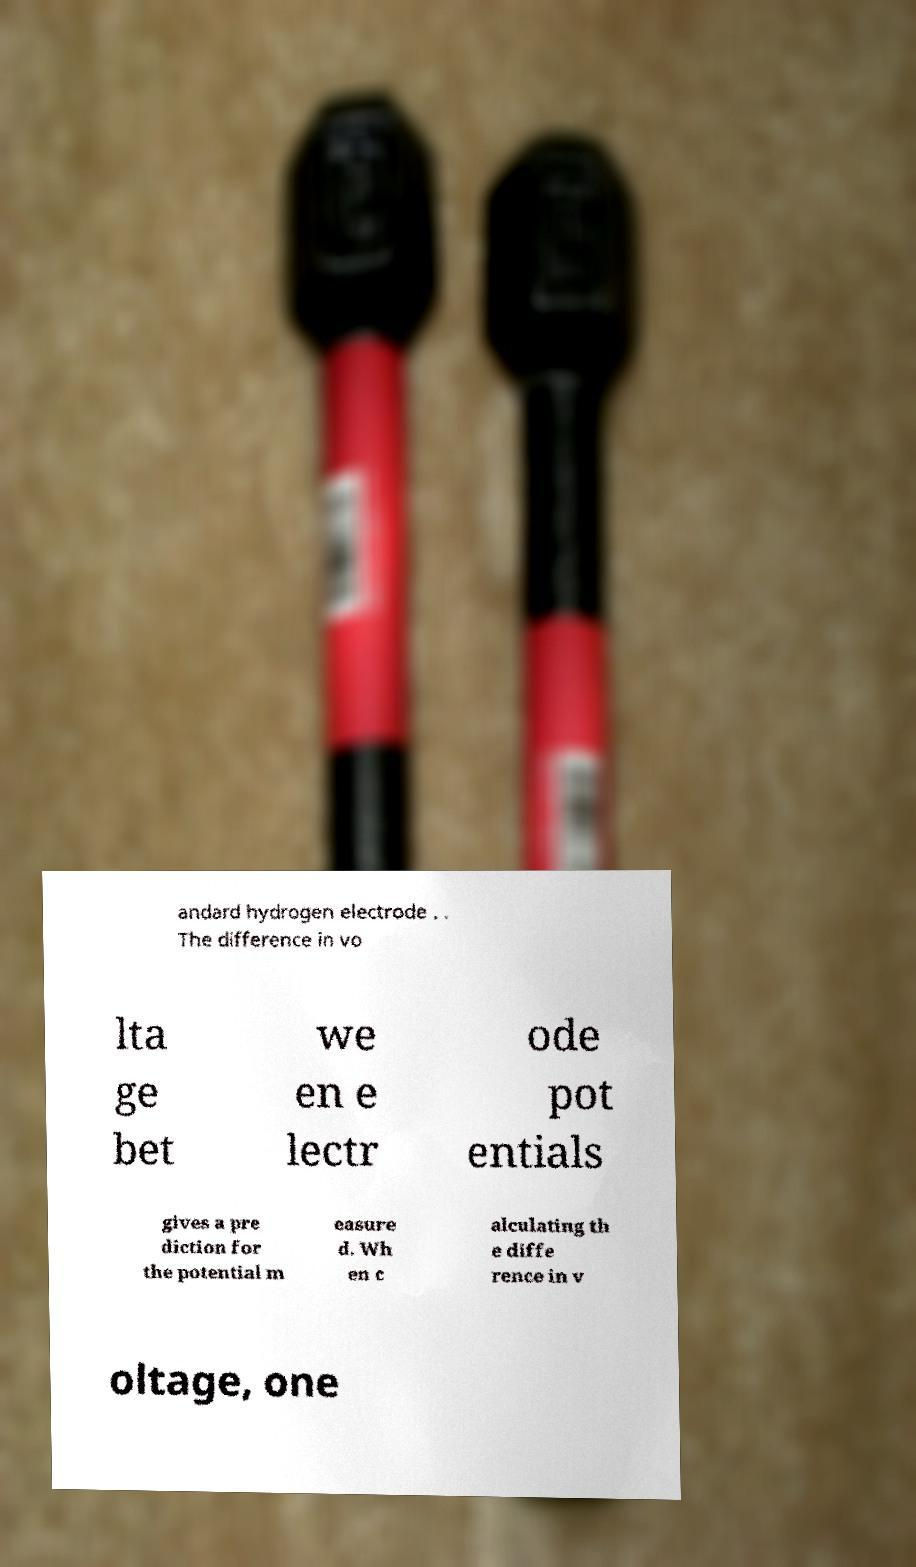Can you read and provide the text displayed in the image?This photo seems to have some interesting text. Can you extract and type it out for me? andard hydrogen electrode . . The difference in vo lta ge bet we en e lectr ode pot entials gives a pre diction for the potential m easure d. Wh en c alculating th e diffe rence in v oltage, one 